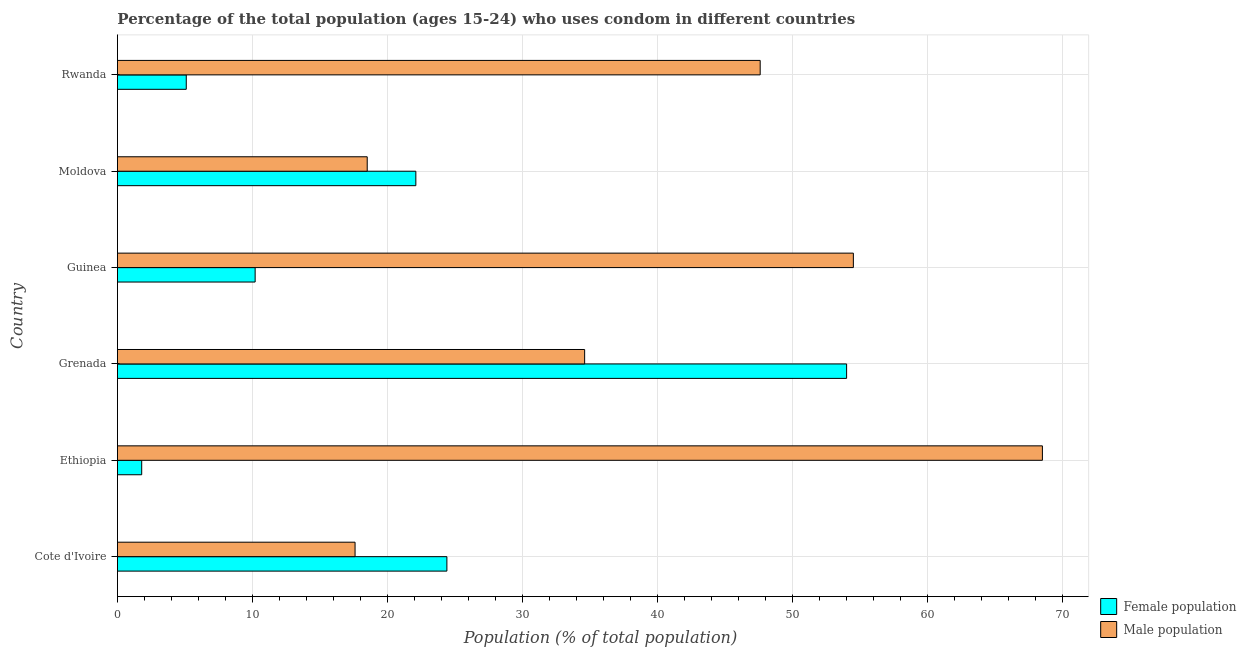Are the number of bars per tick equal to the number of legend labels?
Provide a succinct answer. Yes. Are the number of bars on each tick of the Y-axis equal?
Your answer should be compact. Yes. How many bars are there on the 1st tick from the top?
Make the answer very short. 2. How many bars are there on the 3rd tick from the bottom?
Give a very brief answer. 2. What is the label of the 6th group of bars from the top?
Your answer should be compact. Cote d'Ivoire. In how many cases, is the number of bars for a given country not equal to the number of legend labels?
Your answer should be very brief. 0. What is the female population in Rwanda?
Provide a short and direct response. 5.1. Across all countries, what is the maximum male population?
Make the answer very short. 68.5. Across all countries, what is the minimum female population?
Provide a succinct answer. 1.8. In which country was the female population maximum?
Provide a short and direct response. Grenada. In which country was the male population minimum?
Provide a succinct answer. Cote d'Ivoire. What is the total male population in the graph?
Your answer should be very brief. 241.3. What is the difference between the female population in Cote d'Ivoire and that in Grenada?
Offer a very short reply. -29.6. What is the difference between the female population in Ethiopia and the male population in Guinea?
Keep it short and to the point. -52.7. What is the average female population per country?
Provide a succinct answer. 19.6. In how many countries, is the male population greater than 68 %?
Offer a terse response. 1. What is the ratio of the male population in Ethiopia to that in Guinea?
Your response must be concise. 1.26. Is the difference between the male population in Cote d'Ivoire and Grenada greater than the difference between the female population in Cote d'Ivoire and Grenada?
Make the answer very short. Yes. What is the difference between the highest and the lowest male population?
Your answer should be compact. 50.9. In how many countries, is the female population greater than the average female population taken over all countries?
Provide a succinct answer. 3. Is the sum of the female population in Guinea and Moldova greater than the maximum male population across all countries?
Provide a short and direct response. No. What does the 1st bar from the top in Guinea represents?
Your answer should be very brief. Male population. What does the 1st bar from the bottom in Grenada represents?
Your answer should be very brief. Female population. How many bars are there?
Give a very brief answer. 12. What is the difference between two consecutive major ticks on the X-axis?
Offer a very short reply. 10. Does the graph contain any zero values?
Your response must be concise. No. Does the graph contain grids?
Keep it short and to the point. Yes. How are the legend labels stacked?
Provide a short and direct response. Vertical. What is the title of the graph?
Provide a succinct answer. Percentage of the total population (ages 15-24) who uses condom in different countries. Does "Revenue" appear as one of the legend labels in the graph?
Offer a very short reply. No. What is the label or title of the X-axis?
Your answer should be very brief. Population (% of total population) . What is the label or title of the Y-axis?
Make the answer very short. Country. What is the Population (% of total population)  in Female population in Cote d'Ivoire?
Provide a succinct answer. 24.4. What is the Population (% of total population)  in Male population in Ethiopia?
Offer a very short reply. 68.5. What is the Population (% of total population)  in Male population in Grenada?
Your answer should be compact. 34.6. What is the Population (% of total population)  of Male population in Guinea?
Ensure brevity in your answer.  54.5. What is the Population (% of total population)  of Female population in Moldova?
Offer a terse response. 22.1. What is the Population (% of total population)  in Female population in Rwanda?
Your response must be concise. 5.1. What is the Population (% of total population)  of Male population in Rwanda?
Keep it short and to the point. 47.6. Across all countries, what is the maximum Population (% of total population)  in Male population?
Make the answer very short. 68.5. What is the total Population (% of total population)  in Female population in the graph?
Offer a very short reply. 117.6. What is the total Population (% of total population)  of Male population in the graph?
Make the answer very short. 241.3. What is the difference between the Population (% of total population)  in Female population in Cote d'Ivoire and that in Ethiopia?
Make the answer very short. 22.6. What is the difference between the Population (% of total population)  in Male population in Cote d'Ivoire and that in Ethiopia?
Give a very brief answer. -50.9. What is the difference between the Population (% of total population)  in Female population in Cote d'Ivoire and that in Grenada?
Provide a short and direct response. -29.6. What is the difference between the Population (% of total population)  of Male population in Cote d'Ivoire and that in Grenada?
Your answer should be compact. -17. What is the difference between the Population (% of total population)  in Female population in Cote d'Ivoire and that in Guinea?
Offer a very short reply. 14.2. What is the difference between the Population (% of total population)  of Male population in Cote d'Ivoire and that in Guinea?
Give a very brief answer. -36.9. What is the difference between the Population (% of total population)  in Female population in Cote d'Ivoire and that in Rwanda?
Offer a terse response. 19.3. What is the difference between the Population (% of total population)  in Female population in Ethiopia and that in Grenada?
Provide a short and direct response. -52.2. What is the difference between the Population (% of total population)  of Male population in Ethiopia and that in Grenada?
Your response must be concise. 33.9. What is the difference between the Population (% of total population)  in Female population in Ethiopia and that in Moldova?
Make the answer very short. -20.3. What is the difference between the Population (% of total population)  of Male population in Ethiopia and that in Moldova?
Make the answer very short. 50. What is the difference between the Population (% of total population)  in Male population in Ethiopia and that in Rwanda?
Keep it short and to the point. 20.9. What is the difference between the Population (% of total population)  of Female population in Grenada and that in Guinea?
Offer a terse response. 43.8. What is the difference between the Population (% of total population)  of Male population in Grenada and that in Guinea?
Keep it short and to the point. -19.9. What is the difference between the Population (% of total population)  of Female population in Grenada and that in Moldova?
Give a very brief answer. 31.9. What is the difference between the Population (% of total population)  of Male population in Grenada and that in Moldova?
Make the answer very short. 16.1. What is the difference between the Population (% of total population)  in Female population in Grenada and that in Rwanda?
Your response must be concise. 48.9. What is the difference between the Population (% of total population)  in Male population in Guinea and that in Moldova?
Provide a short and direct response. 36. What is the difference between the Population (% of total population)  of Female population in Guinea and that in Rwanda?
Make the answer very short. 5.1. What is the difference between the Population (% of total population)  of Female population in Moldova and that in Rwanda?
Ensure brevity in your answer.  17. What is the difference between the Population (% of total population)  in Male population in Moldova and that in Rwanda?
Give a very brief answer. -29.1. What is the difference between the Population (% of total population)  in Female population in Cote d'Ivoire and the Population (% of total population)  in Male population in Ethiopia?
Keep it short and to the point. -44.1. What is the difference between the Population (% of total population)  of Female population in Cote d'Ivoire and the Population (% of total population)  of Male population in Grenada?
Offer a very short reply. -10.2. What is the difference between the Population (% of total population)  in Female population in Cote d'Ivoire and the Population (% of total population)  in Male population in Guinea?
Keep it short and to the point. -30.1. What is the difference between the Population (% of total population)  in Female population in Cote d'Ivoire and the Population (% of total population)  in Male population in Moldova?
Offer a very short reply. 5.9. What is the difference between the Population (% of total population)  of Female population in Cote d'Ivoire and the Population (% of total population)  of Male population in Rwanda?
Your response must be concise. -23.2. What is the difference between the Population (% of total population)  of Female population in Ethiopia and the Population (% of total population)  of Male population in Grenada?
Offer a terse response. -32.8. What is the difference between the Population (% of total population)  in Female population in Ethiopia and the Population (% of total population)  in Male population in Guinea?
Offer a very short reply. -52.7. What is the difference between the Population (% of total population)  of Female population in Ethiopia and the Population (% of total population)  of Male population in Moldova?
Your answer should be compact. -16.7. What is the difference between the Population (% of total population)  of Female population in Ethiopia and the Population (% of total population)  of Male population in Rwanda?
Offer a terse response. -45.8. What is the difference between the Population (% of total population)  in Female population in Grenada and the Population (% of total population)  in Male population in Moldova?
Provide a short and direct response. 35.5. What is the difference between the Population (% of total population)  of Female population in Grenada and the Population (% of total population)  of Male population in Rwanda?
Give a very brief answer. 6.4. What is the difference between the Population (% of total population)  of Female population in Guinea and the Population (% of total population)  of Male population in Rwanda?
Offer a very short reply. -37.4. What is the difference between the Population (% of total population)  of Female population in Moldova and the Population (% of total population)  of Male population in Rwanda?
Make the answer very short. -25.5. What is the average Population (% of total population)  in Female population per country?
Make the answer very short. 19.6. What is the average Population (% of total population)  of Male population per country?
Offer a very short reply. 40.22. What is the difference between the Population (% of total population)  of Female population and Population (% of total population)  of Male population in Cote d'Ivoire?
Offer a terse response. 6.8. What is the difference between the Population (% of total population)  of Female population and Population (% of total population)  of Male population in Ethiopia?
Offer a very short reply. -66.7. What is the difference between the Population (% of total population)  in Female population and Population (% of total population)  in Male population in Guinea?
Your response must be concise. -44.3. What is the difference between the Population (% of total population)  of Female population and Population (% of total population)  of Male population in Rwanda?
Your answer should be compact. -42.5. What is the ratio of the Population (% of total population)  in Female population in Cote d'Ivoire to that in Ethiopia?
Make the answer very short. 13.56. What is the ratio of the Population (% of total population)  in Male population in Cote d'Ivoire to that in Ethiopia?
Ensure brevity in your answer.  0.26. What is the ratio of the Population (% of total population)  of Female population in Cote d'Ivoire to that in Grenada?
Provide a short and direct response. 0.45. What is the ratio of the Population (% of total population)  in Male population in Cote d'Ivoire to that in Grenada?
Your answer should be compact. 0.51. What is the ratio of the Population (% of total population)  of Female population in Cote d'Ivoire to that in Guinea?
Ensure brevity in your answer.  2.39. What is the ratio of the Population (% of total population)  of Male population in Cote d'Ivoire to that in Guinea?
Make the answer very short. 0.32. What is the ratio of the Population (% of total population)  of Female population in Cote d'Ivoire to that in Moldova?
Ensure brevity in your answer.  1.1. What is the ratio of the Population (% of total population)  of Male population in Cote d'Ivoire to that in Moldova?
Your response must be concise. 0.95. What is the ratio of the Population (% of total population)  in Female population in Cote d'Ivoire to that in Rwanda?
Your answer should be very brief. 4.78. What is the ratio of the Population (% of total population)  of Male population in Cote d'Ivoire to that in Rwanda?
Provide a succinct answer. 0.37. What is the ratio of the Population (% of total population)  of Female population in Ethiopia to that in Grenada?
Keep it short and to the point. 0.03. What is the ratio of the Population (% of total population)  of Male population in Ethiopia to that in Grenada?
Provide a short and direct response. 1.98. What is the ratio of the Population (% of total population)  in Female population in Ethiopia to that in Guinea?
Offer a terse response. 0.18. What is the ratio of the Population (% of total population)  of Male population in Ethiopia to that in Guinea?
Offer a terse response. 1.26. What is the ratio of the Population (% of total population)  of Female population in Ethiopia to that in Moldova?
Make the answer very short. 0.08. What is the ratio of the Population (% of total population)  in Male population in Ethiopia to that in Moldova?
Provide a succinct answer. 3.7. What is the ratio of the Population (% of total population)  in Female population in Ethiopia to that in Rwanda?
Give a very brief answer. 0.35. What is the ratio of the Population (% of total population)  of Male population in Ethiopia to that in Rwanda?
Ensure brevity in your answer.  1.44. What is the ratio of the Population (% of total population)  of Female population in Grenada to that in Guinea?
Provide a short and direct response. 5.29. What is the ratio of the Population (% of total population)  of Male population in Grenada to that in Guinea?
Your answer should be compact. 0.63. What is the ratio of the Population (% of total population)  in Female population in Grenada to that in Moldova?
Provide a short and direct response. 2.44. What is the ratio of the Population (% of total population)  in Male population in Grenada to that in Moldova?
Keep it short and to the point. 1.87. What is the ratio of the Population (% of total population)  in Female population in Grenada to that in Rwanda?
Provide a succinct answer. 10.59. What is the ratio of the Population (% of total population)  in Male population in Grenada to that in Rwanda?
Keep it short and to the point. 0.73. What is the ratio of the Population (% of total population)  in Female population in Guinea to that in Moldova?
Keep it short and to the point. 0.46. What is the ratio of the Population (% of total population)  of Male population in Guinea to that in Moldova?
Make the answer very short. 2.95. What is the ratio of the Population (% of total population)  in Male population in Guinea to that in Rwanda?
Ensure brevity in your answer.  1.15. What is the ratio of the Population (% of total population)  in Female population in Moldova to that in Rwanda?
Provide a short and direct response. 4.33. What is the ratio of the Population (% of total population)  of Male population in Moldova to that in Rwanda?
Make the answer very short. 0.39. What is the difference between the highest and the second highest Population (% of total population)  in Female population?
Ensure brevity in your answer.  29.6. What is the difference between the highest and the lowest Population (% of total population)  of Female population?
Give a very brief answer. 52.2. What is the difference between the highest and the lowest Population (% of total population)  in Male population?
Your answer should be very brief. 50.9. 